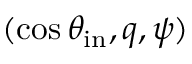<formula> <loc_0><loc_0><loc_500><loc_500>( \cos \theta _ { i n } , q , \psi )</formula> 